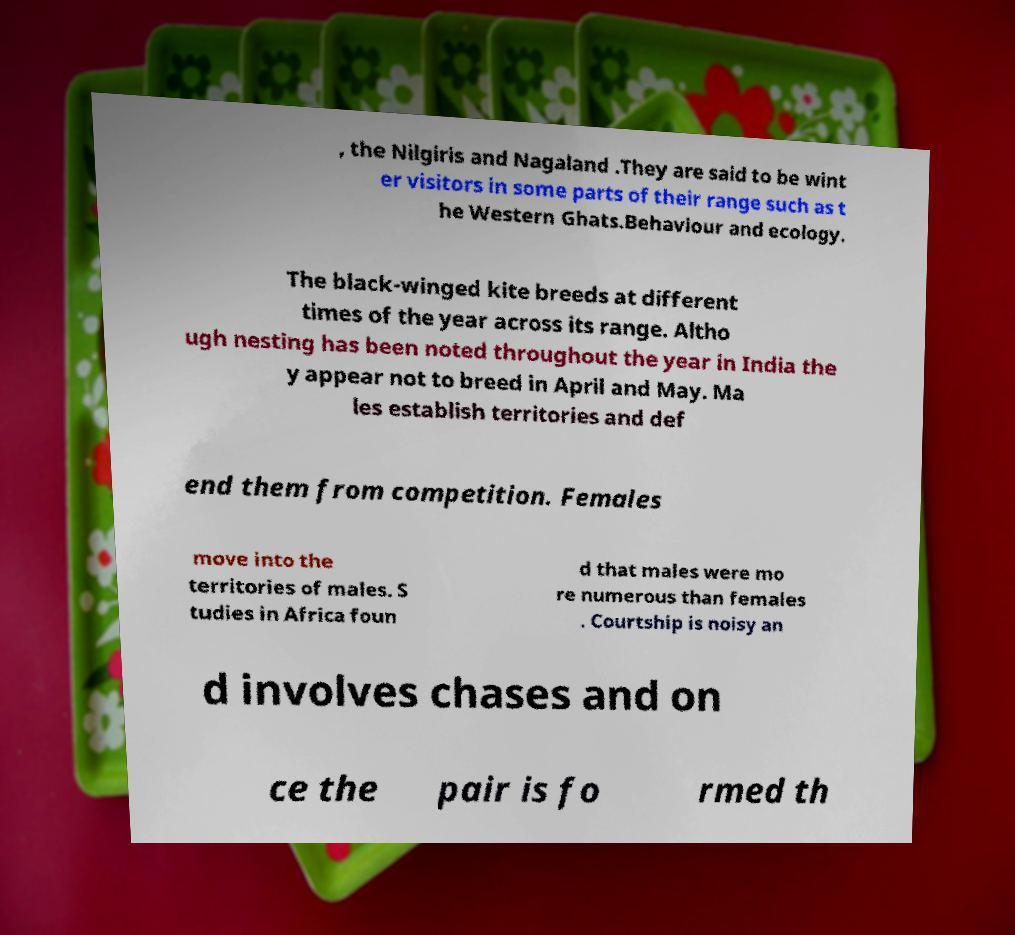There's text embedded in this image that I need extracted. Can you transcribe it verbatim? , the Nilgiris and Nagaland .They are said to be wint er visitors in some parts of their range such as t he Western Ghats.Behaviour and ecology. The black-winged kite breeds at different times of the year across its range. Altho ugh nesting has been noted throughout the year in India the y appear not to breed in April and May. Ma les establish territories and def end them from competition. Females move into the territories of males. S tudies in Africa foun d that males were mo re numerous than females . Courtship is noisy an d involves chases and on ce the pair is fo rmed th 